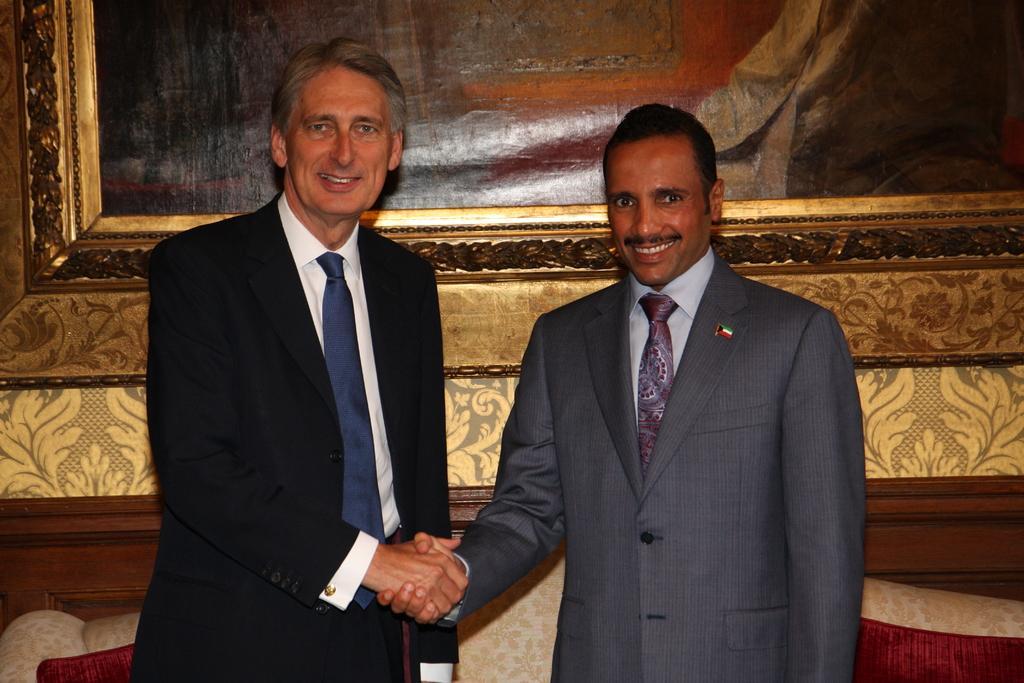In one or two sentences, can you explain what this image depicts? In this picture I can see two persons standing and smiling by handshaking each other, and in the background there is a frame attached to the wall and there are some objects. 